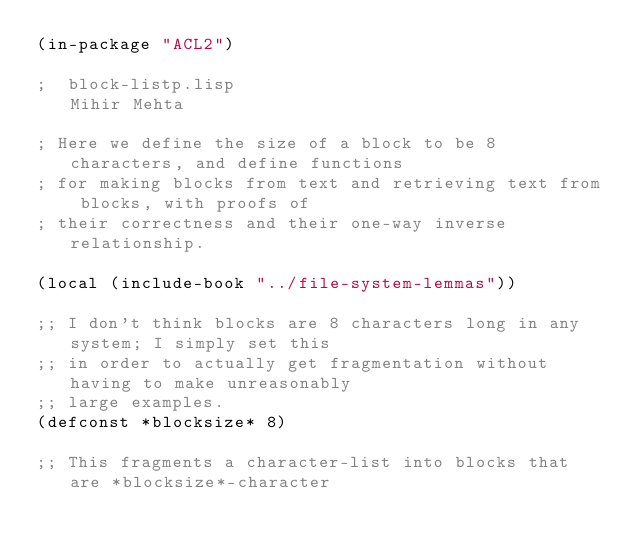<code> <loc_0><loc_0><loc_500><loc_500><_Lisp_>(in-package "ACL2")

;  block-listp.lisp                                  Mihir Mehta

; Here we define the size of a block to be 8 characters, and define functions
; for making blocks from text and retrieving text from blocks, with proofs of
; their correctness and their one-way inverse relationship.

(local (include-book "../file-system-lemmas"))

;; I don't think blocks are 8 characters long in any system; I simply set this
;; in order to actually get fragmentation without having to make unreasonably
;; large examples.
(defconst *blocksize* 8)

;; This fragments a character-list into blocks that are *blocksize*-character</code> 